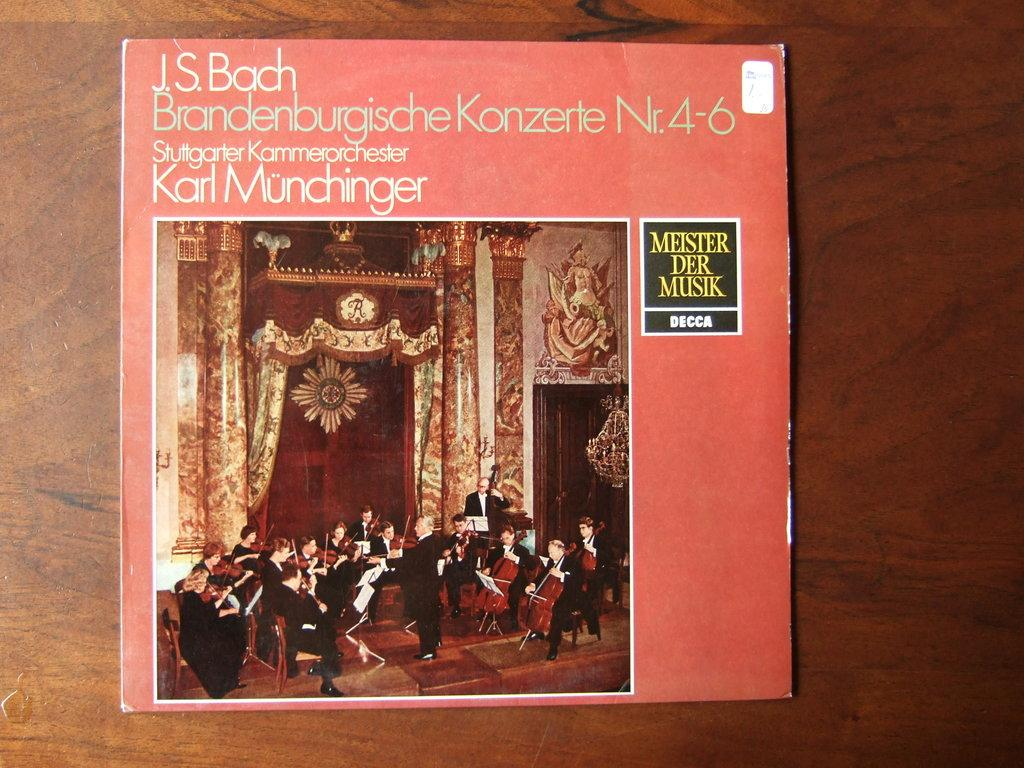<image>
Summarize the visual content of the image. An album cover for J.S. Bach music shows an orchestra. 